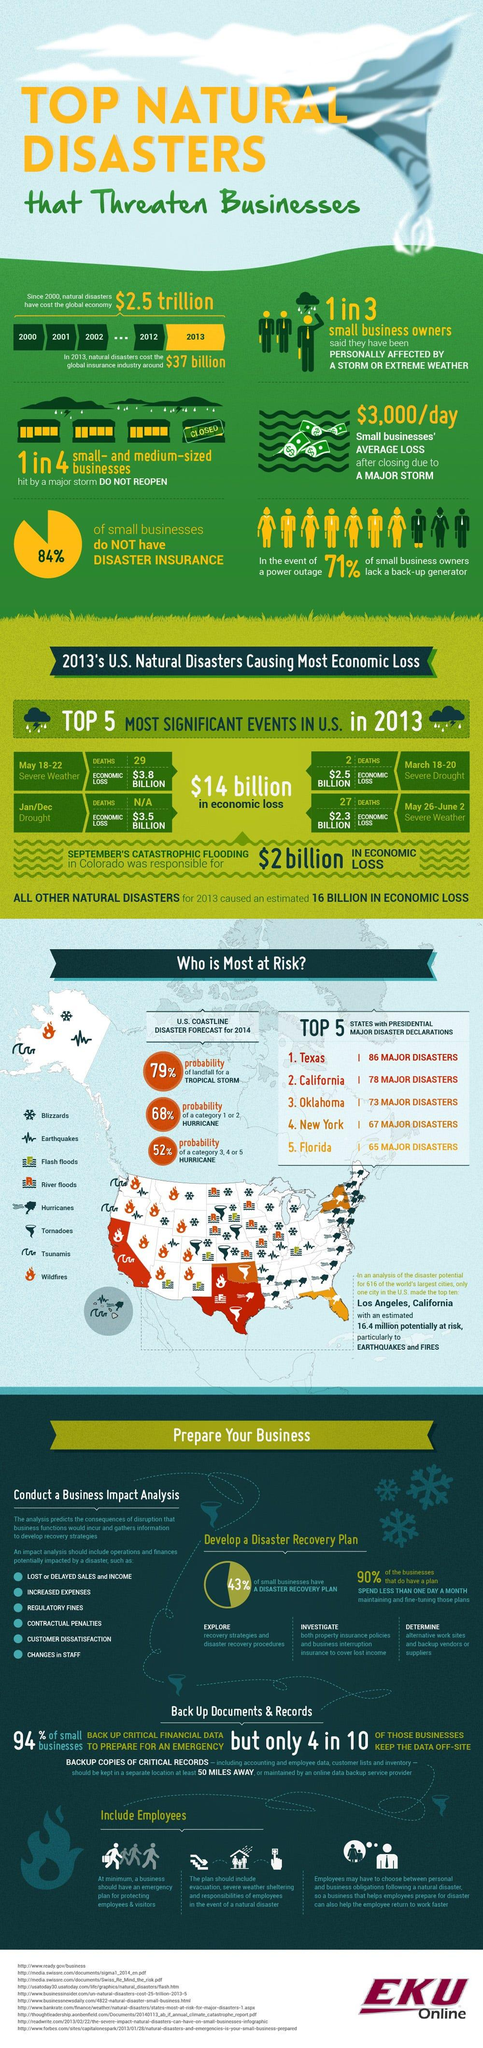Specify some key components in this picture. There is a 68% chance that a category 1 or 2 hurricane will affect the U.S. coastline in 2014. According to data from 2014, there is a 52% probability of a category 3, 4, or 5 hurricane hitting the U.S. coastline. According to information from May 18-22, 2013, a total of 29 people were killed due to severe weather conditions in the United States. During the period of March 18-20, 2013, severe drought killed a number of people in the United States. The severe weather conditions in the U.S. during May 26- June 2, 2013 resulted in the death of 27 people. 